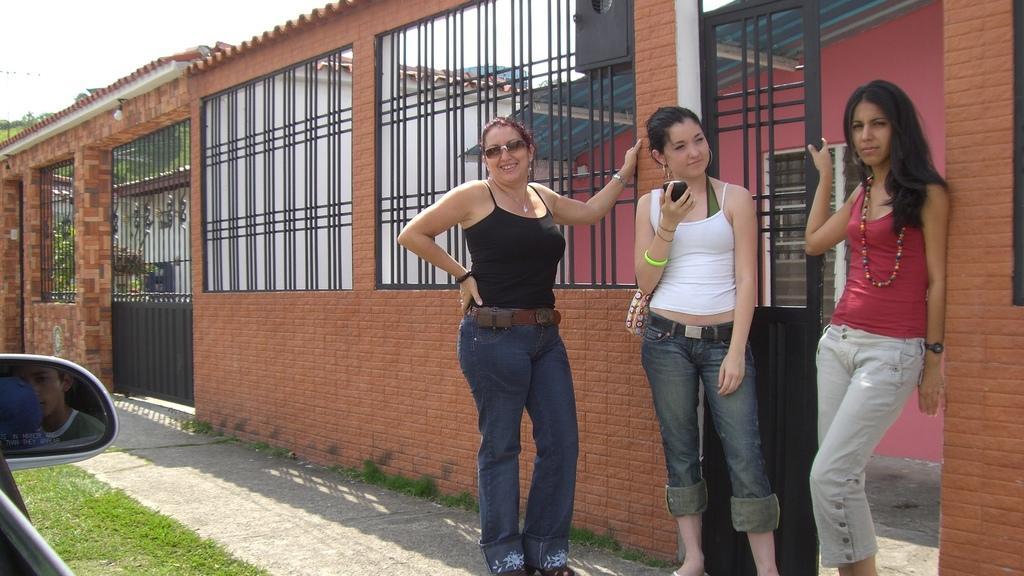Please provide a concise description of this image. In this image we can see three ladies standing. One lady is wearing goggles. Another lady is holding mobile and wearing a bag. Another lady is wearing a watch. There is a wall with grille windows. In the back there is a building with windows. On the ground there is grass. In the bottom left corner we can see mirror of the car. Also there is a bulb on the top of the wall. 